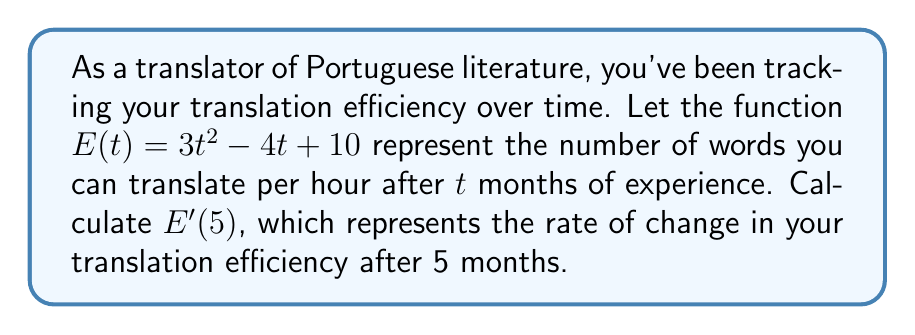Can you answer this question? To solve this problem, we need to follow these steps:

1) First, we need to find the derivative of the function $E(t)$. 
   The function is $E(t) = 3t^2 - 4t + 10$

2) To find $E'(t)$, we use the power rule and the constant rule:
   - For $3t^2$: The derivative is $3 \cdot 2t = 6t$
   - For $-4t$: The derivative is $-4$
   - For $10$: The derivative of a constant is 0

3) Therefore, $E'(t) = 6t - 4$

4) Now that we have $E'(t)$, we need to calculate $E'(5)$:
   $E'(5) = 6(5) - 4 = 30 - 4 = 26$

5) Interpret the result: After 5 months, your translation efficiency is increasing at a rate of 26 words per hour per month.
Answer: $E'(5) = 26$ 